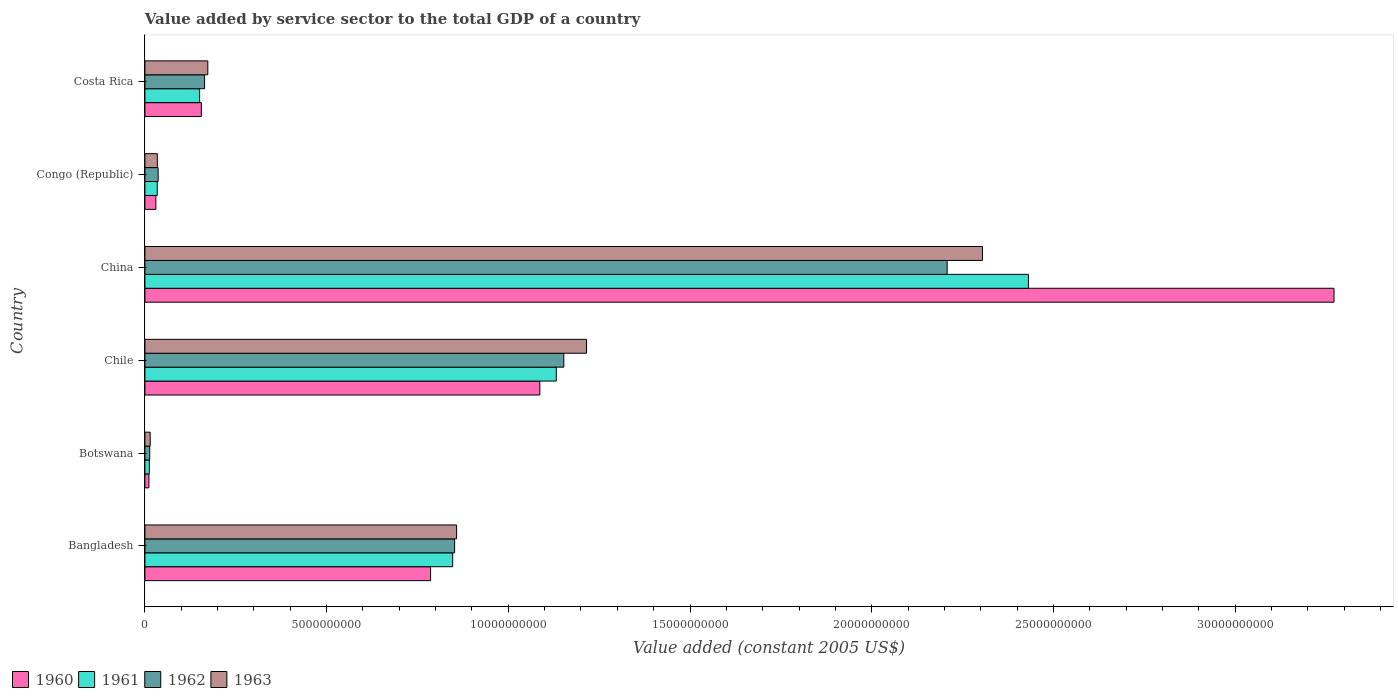How many different coloured bars are there?
Keep it short and to the point. 4. Are the number of bars per tick equal to the number of legend labels?
Give a very brief answer. Yes. How many bars are there on the 4th tick from the top?
Provide a succinct answer. 4. How many bars are there on the 3rd tick from the bottom?
Your answer should be very brief. 4. In how many cases, is the number of bars for a given country not equal to the number of legend labels?
Your response must be concise. 0. What is the value added by service sector in 1961 in Costa Rica?
Offer a very short reply. 1.51e+09. Across all countries, what is the maximum value added by service sector in 1963?
Make the answer very short. 2.30e+1. Across all countries, what is the minimum value added by service sector in 1961?
Provide a succinct answer. 1.22e+08. In which country was the value added by service sector in 1960 maximum?
Provide a short and direct response. China. In which country was the value added by service sector in 1960 minimum?
Offer a terse response. Botswana. What is the total value added by service sector in 1962 in the graph?
Keep it short and to the point. 4.43e+1. What is the difference between the value added by service sector in 1963 in Bangladesh and that in China?
Provide a succinct answer. -1.45e+1. What is the difference between the value added by service sector in 1963 in Botswana and the value added by service sector in 1961 in Costa Rica?
Your answer should be very brief. -1.36e+09. What is the average value added by service sector in 1960 per country?
Provide a short and direct response. 8.90e+09. What is the difference between the value added by service sector in 1960 and value added by service sector in 1962 in China?
Provide a short and direct response. 1.06e+1. What is the ratio of the value added by service sector in 1963 in Botswana to that in China?
Your answer should be compact. 0.01. Is the value added by service sector in 1963 in Botswana less than that in Congo (Republic)?
Offer a very short reply. Yes. Is the difference between the value added by service sector in 1960 in Congo (Republic) and Costa Rica greater than the difference between the value added by service sector in 1962 in Congo (Republic) and Costa Rica?
Offer a terse response. Yes. What is the difference between the highest and the second highest value added by service sector in 1963?
Provide a succinct answer. 1.09e+1. What is the difference between the highest and the lowest value added by service sector in 1963?
Give a very brief answer. 2.29e+1. What does the 3rd bar from the top in Costa Rica represents?
Your answer should be very brief. 1961. Is it the case that in every country, the sum of the value added by service sector in 1963 and value added by service sector in 1961 is greater than the value added by service sector in 1960?
Make the answer very short. Yes. How many bars are there?
Your answer should be very brief. 24. What is the difference between two consecutive major ticks on the X-axis?
Your response must be concise. 5.00e+09. Does the graph contain any zero values?
Your answer should be compact. No. Does the graph contain grids?
Ensure brevity in your answer.  No. How many legend labels are there?
Your answer should be compact. 4. How are the legend labels stacked?
Your answer should be very brief. Horizontal. What is the title of the graph?
Provide a succinct answer. Value added by service sector to the total GDP of a country. Does "1995" appear as one of the legend labels in the graph?
Give a very brief answer. No. What is the label or title of the X-axis?
Your answer should be very brief. Value added (constant 2005 US$). What is the label or title of the Y-axis?
Offer a very short reply. Country. What is the Value added (constant 2005 US$) in 1960 in Bangladesh?
Your answer should be very brief. 7.86e+09. What is the Value added (constant 2005 US$) of 1961 in Bangladesh?
Provide a succinct answer. 8.47e+09. What is the Value added (constant 2005 US$) of 1962 in Bangladesh?
Ensure brevity in your answer.  8.52e+09. What is the Value added (constant 2005 US$) of 1963 in Bangladesh?
Keep it short and to the point. 8.58e+09. What is the Value added (constant 2005 US$) of 1960 in Botswana?
Your answer should be compact. 1.11e+08. What is the Value added (constant 2005 US$) in 1961 in Botswana?
Your response must be concise. 1.22e+08. What is the Value added (constant 2005 US$) in 1962 in Botswana?
Provide a succinct answer. 1.32e+08. What is the Value added (constant 2005 US$) of 1963 in Botswana?
Provide a succinct answer. 1.45e+08. What is the Value added (constant 2005 US$) of 1960 in Chile?
Your answer should be compact. 1.09e+1. What is the Value added (constant 2005 US$) in 1961 in Chile?
Give a very brief answer. 1.13e+1. What is the Value added (constant 2005 US$) of 1962 in Chile?
Your response must be concise. 1.15e+1. What is the Value added (constant 2005 US$) in 1963 in Chile?
Ensure brevity in your answer.  1.22e+1. What is the Value added (constant 2005 US$) of 1960 in China?
Ensure brevity in your answer.  3.27e+1. What is the Value added (constant 2005 US$) in 1961 in China?
Ensure brevity in your answer.  2.43e+1. What is the Value added (constant 2005 US$) in 1962 in China?
Give a very brief answer. 2.21e+1. What is the Value added (constant 2005 US$) of 1963 in China?
Ensure brevity in your answer.  2.30e+1. What is the Value added (constant 2005 US$) in 1960 in Congo (Republic)?
Keep it short and to the point. 3.02e+08. What is the Value added (constant 2005 US$) in 1961 in Congo (Republic)?
Provide a succinct answer. 3.39e+08. What is the Value added (constant 2005 US$) of 1962 in Congo (Republic)?
Provide a succinct answer. 3.64e+08. What is the Value added (constant 2005 US$) in 1963 in Congo (Republic)?
Offer a very short reply. 3.42e+08. What is the Value added (constant 2005 US$) in 1960 in Costa Rica?
Your answer should be very brief. 1.55e+09. What is the Value added (constant 2005 US$) of 1961 in Costa Rica?
Give a very brief answer. 1.51e+09. What is the Value added (constant 2005 US$) of 1962 in Costa Rica?
Your response must be concise. 1.64e+09. What is the Value added (constant 2005 US$) of 1963 in Costa Rica?
Give a very brief answer. 1.73e+09. Across all countries, what is the maximum Value added (constant 2005 US$) in 1960?
Your answer should be very brief. 3.27e+1. Across all countries, what is the maximum Value added (constant 2005 US$) in 1961?
Offer a terse response. 2.43e+1. Across all countries, what is the maximum Value added (constant 2005 US$) of 1962?
Your answer should be very brief. 2.21e+1. Across all countries, what is the maximum Value added (constant 2005 US$) in 1963?
Keep it short and to the point. 2.30e+1. Across all countries, what is the minimum Value added (constant 2005 US$) of 1960?
Provide a short and direct response. 1.11e+08. Across all countries, what is the minimum Value added (constant 2005 US$) in 1961?
Offer a very short reply. 1.22e+08. Across all countries, what is the minimum Value added (constant 2005 US$) of 1962?
Your response must be concise. 1.32e+08. Across all countries, what is the minimum Value added (constant 2005 US$) of 1963?
Your answer should be very brief. 1.45e+08. What is the total Value added (constant 2005 US$) in 1960 in the graph?
Provide a short and direct response. 5.34e+1. What is the total Value added (constant 2005 US$) in 1961 in the graph?
Offer a very short reply. 4.61e+1. What is the total Value added (constant 2005 US$) of 1962 in the graph?
Your answer should be compact. 4.43e+1. What is the total Value added (constant 2005 US$) of 1963 in the graph?
Keep it short and to the point. 4.60e+1. What is the difference between the Value added (constant 2005 US$) of 1960 in Bangladesh and that in Botswana?
Offer a terse response. 7.75e+09. What is the difference between the Value added (constant 2005 US$) in 1961 in Bangladesh and that in Botswana?
Offer a terse response. 8.35e+09. What is the difference between the Value added (constant 2005 US$) of 1962 in Bangladesh and that in Botswana?
Offer a very short reply. 8.39e+09. What is the difference between the Value added (constant 2005 US$) of 1963 in Bangladesh and that in Botswana?
Offer a terse response. 8.43e+09. What is the difference between the Value added (constant 2005 US$) in 1960 in Bangladesh and that in Chile?
Make the answer very short. -3.01e+09. What is the difference between the Value added (constant 2005 US$) in 1961 in Bangladesh and that in Chile?
Provide a succinct answer. -2.85e+09. What is the difference between the Value added (constant 2005 US$) of 1962 in Bangladesh and that in Chile?
Keep it short and to the point. -3.00e+09. What is the difference between the Value added (constant 2005 US$) of 1963 in Bangladesh and that in Chile?
Your answer should be very brief. -3.58e+09. What is the difference between the Value added (constant 2005 US$) of 1960 in Bangladesh and that in China?
Ensure brevity in your answer.  -2.49e+1. What is the difference between the Value added (constant 2005 US$) of 1961 in Bangladesh and that in China?
Offer a terse response. -1.58e+1. What is the difference between the Value added (constant 2005 US$) in 1962 in Bangladesh and that in China?
Make the answer very short. -1.36e+1. What is the difference between the Value added (constant 2005 US$) in 1963 in Bangladesh and that in China?
Keep it short and to the point. -1.45e+1. What is the difference between the Value added (constant 2005 US$) in 1960 in Bangladesh and that in Congo (Republic)?
Your answer should be very brief. 7.56e+09. What is the difference between the Value added (constant 2005 US$) of 1961 in Bangladesh and that in Congo (Republic)?
Make the answer very short. 8.13e+09. What is the difference between the Value added (constant 2005 US$) in 1962 in Bangladesh and that in Congo (Republic)?
Your response must be concise. 8.16e+09. What is the difference between the Value added (constant 2005 US$) in 1963 in Bangladesh and that in Congo (Republic)?
Provide a short and direct response. 8.24e+09. What is the difference between the Value added (constant 2005 US$) in 1960 in Bangladesh and that in Costa Rica?
Give a very brief answer. 6.31e+09. What is the difference between the Value added (constant 2005 US$) of 1961 in Bangladesh and that in Costa Rica?
Your answer should be compact. 6.96e+09. What is the difference between the Value added (constant 2005 US$) of 1962 in Bangladesh and that in Costa Rica?
Keep it short and to the point. 6.88e+09. What is the difference between the Value added (constant 2005 US$) of 1963 in Bangladesh and that in Costa Rica?
Provide a succinct answer. 6.85e+09. What is the difference between the Value added (constant 2005 US$) of 1960 in Botswana and that in Chile?
Your answer should be very brief. -1.08e+1. What is the difference between the Value added (constant 2005 US$) in 1961 in Botswana and that in Chile?
Your response must be concise. -1.12e+1. What is the difference between the Value added (constant 2005 US$) in 1962 in Botswana and that in Chile?
Your response must be concise. -1.14e+1. What is the difference between the Value added (constant 2005 US$) of 1963 in Botswana and that in Chile?
Provide a short and direct response. -1.20e+1. What is the difference between the Value added (constant 2005 US$) in 1960 in Botswana and that in China?
Keep it short and to the point. -3.26e+1. What is the difference between the Value added (constant 2005 US$) of 1961 in Botswana and that in China?
Give a very brief answer. -2.42e+1. What is the difference between the Value added (constant 2005 US$) of 1962 in Botswana and that in China?
Your answer should be very brief. -2.19e+1. What is the difference between the Value added (constant 2005 US$) in 1963 in Botswana and that in China?
Your answer should be very brief. -2.29e+1. What is the difference between the Value added (constant 2005 US$) of 1960 in Botswana and that in Congo (Republic)?
Your response must be concise. -1.91e+08. What is the difference between the Value added (constant 2005 US$) of 1961 in Botswana and that in Congo (Republic)?
Make the answer very short. -2.17e+08. What is the difference between the Value added (constant 2005 US$) of 1962 in Botswana and that in Congo (Republic)?
Make the answer very short. -2.32e+08. What is the difference between the Value added (constant 2005 US$) of 1963 in Botswana and that in Congo (Republic)?
Make the answer very short. -1.97e+08. What is the difference between the Value added (constant 2005 US$) of 1960 in Botswana and that in Costa Rica?
Your response must be concise. -1.44e+09. What is the difference between the Value added (constant 2005 US$) of 1961 in Botswana and that in Costa Rica?
Provide a succinct answer. -1.38e+09. What is the difference between the Value added (constant 2005 US$) of 1962 in Botswana and that in Costa Rica?
Your answer should be very brief. -1.51e+09. What is the difference between the Value added (constant 2005 US$) of 1963 in Botswana and that in Costa Rica?
Provide a succinct answer. -1.59e+09. What is the difference between the Value added (constant 2005 US$) of 1960 in Chile and that in China?
Make the answer very short. -2.19e+1. What is the difference between the Value added (constant 2005 US$) of 1961 in Chile and that in China?
Your answer should be very brief. -1.30e+1. What is the difference between the Value added (constant 2005 US$) in 1962 in Chile and that in China?
Ensure brevity in your answer.  -1.05e+1. What is the difference between the Value added (constant 2005 US$) of 1963 in Chile and that in China?
Provide a succinct answer. -1.09e+1. What is the difference between the Value added (constant 2005 US$) of 1960 in Chile and that in Congo (Republic)?
Offer a terse response. 1.06e+1. What is the difference between the Value added (constant 2005 US$) in 1961 in Chile and that in Congo (Republic)?
Provide a succinct answer. 1.10e+1. What is the difference between the Value added (constant 2005 US$) of 1962 in Chile and that in Congo (Republic)?
Your response must be concise. 1.12e+1. What is the difference between the Value added (constant 2005 US$) of 1963 in Chile and that in Congo (Republic)?
Provide a succinct answer. 1.18e+1. What is the difference between the Value added (constant 2005 US$) in 1960 in Chile and that in Costa Rica?
Keep it short and to the point. 9.31e+09. What is the difference between the Value added (constant 2005 US$) of 1961 in Chile and that in Costa Rica?
Provide a short and direct response. 9.81e+09. What is the difference between the Value added (constant 2005 US$) in 1962 in Chile and that in Costa Rica?
Your response must be concise. 9.89e+09. What is the difference between the Value added (constant 2005 US$) of 1963 in Chile and that in Costa Rica?
Your answer should be very brief. 1.04e+1. What is the difference between the Value added (constant 2005 US$) in 1960 in China and that in Congo (Republic)?
Keep it short and to the point. 3.24e+1. What is the difference between the Value added (constant 2005 US$) of 1961 in China and that in Congo (Republic)?
Offer a terse response. 2.40e+1. What is the difference between the Value added (constant 2005 US$) in 1962 in China and that in Congo (Republic)?
Offer a very short reply. 2.17e+1. What is the difference between the Value added (constant 2005 US$) of 1963 in China and that in Congo (Republic)?
Your answer should be compact. 2.27e+1. What is the difference between the Value added (constant 2005 US$) of 1960 in China and that in Costa Rica?
Give a very brief answer. 3.12e+1. What is the difference between the Value added (constant 2005 US$) in 1961 in China and that in Costa Rica?
Provide a short and direct response. 2.28e+1. What is the difference between the Value added (constant 2005 US$) of 1962 in China and that in Costa Rica?
Your answer should be very brief. 2.04e+1. What is the difference between the Value added (constant 2005 US$) in 1963 in China and that in Costa Rica?
Offer a terse response. 2.13e+1. What is the difference between the Value added (constant 2005 US$) in 1960 in Congo (Republic) and that in Costa Rica?
Offer a terse response. -1.25e+09. What is the difference between the Value added (constant 2005 US$) of 1961 in Congo (Republic) and that in Costa Rica?
Make the answer very short. -1.17e+09. What is the difference between the Value added (constant 2005 US$) in 1962 in Congo (Republic) and that in Costa Rica?
Your answer should be compact. -1.28e+09. What is the difference between the Value added (constant 2005 US$) in 1963 in Congo (Republic) and that in Costa Rica?
Offer a very short reply. -1.39e+09. What is the difference between the Value added (constant 2005 US$) in 1960 in Bangladesh and the Value added (constant 2005 US$) in 1961 in Botswana?
Your response must be concise. 7.74e+09. What is the difference between the Value added (constant 2005 US$) in 1960 in Bangladesh and the Value added (constant 2005 US$) in 1962 in Botswana?
Ensure brevity in your answer.  7.73e+09. What is the difference between the Value added (constant 2005 US$) in 1960 in Bangladesh and the Value added (constant 2005 US$) in 1963 in Botswana?
Offer a terse response. 7.72e+09. What is the difference between the Value added (constant 2005 US$) in 1961 in Bangladesh and the Value added (constant 2005 US$) in 1962 in Botswana?
Your answer should be very brief. 8.34e+09. What is the difference between the Value added (constant 2005 US$) of 1961 in Bangladesh and the Value added (constant 2005 US$) of 1963 in Botswana?
Your answer should be very brief. 8.32e+09. What is the difference between the Value added (constant 2005 US$) in 1962 in Bangladesh and the Value added (constant 2005 US$) in 1963 in Botswana?
Your answer should be compact. 8.38e+09. What is the difference between the Value added (constant 2005 US$) of 1960 in Bangladesh and the Value added (constant 2005 US$) of 1961 in Chile?
Ensure brevity in your answer.  -3.46e+09. What is the difference between the Value added (constant 2005 US$) in 1960 in Bangladesh and the Value added (constant 2005 US$) in 1962 in Chile?
Your answer should be very brief. -3.67e+09. What is the difference between the Value added (constant 2005 US$) of 1960 in Bangladesh and the Value added (constant 2005 US$) of 1963 in Chile?
Your response must be concise. -4.29e+09. What is the difference between the Value added (constant 2005 US$) of 1961 in Bangladesh and the Value added (constant 2005 US$) of 1962 in Chile?
Offer a very short reply. -3.06e+09. What is the difference between the Value added (constant 2005 US$) in 1961 in Bangladesh and the Value added (constant 2005 US$) in 1963 in Chile?
Your answer should be compact. -3.68e+09. What is the difference between the Value added (constant 2005 US$) in 1962 in Bangladesh and the Value added (constant 2005 US$) in 1963 in Chile?
Provide a succinct answer. -3.63e+09. What is the difference between the Value added (constant 2005 US$) in 1960 in Bangladesh and the Value added (constant 2005 US$) in 1961 in China?
Give a very brief answer. -1.65e+1. What is the difference between the Value added (constant 2005 US$) of 1960 in Bangladesh and the Value added (constant 2005 US$) of 1962 in China?
Offer a terse response. -1.42e+1. What is the difference between the Value added (constant 2005 US$) in 1960 in Bangladesh and the Value added (constant 2005 US$) in 1963 in China?
Your answer should be compact. -1.52e+1. What is the difference between the Value added (constant 2005 US$) in 1961 in Bangladesh and the Value added (constant 2005 US$) in 1962 in China?
Provide a short and direct response. -1.36e+1. What is the difference between the Value added (constant 2005 US$) of 1961 in Bangladesh and the Value added (constant 2005 US$) of 1963 in China?
Give a very brief answer. -1.46e+1. What is the difference between the Value added (constant 2005 US$) in 1962 in Bangladesh and the Value added (constant 2005 US$) in 1963 in China?
Keep it short and to the point. -1.45e+1. What is the difference between the Value added (constant 2005 US$) in 1960 in Bangladesh and the Value added (constant 2005 US$) in 1961 in Congo (Republic)?
Your answer should be very brief. 7.52e+09. What is the difference between the Value added (constant 2005 US$) in 1960 in Bangladesh and the Value added (constant 2005 US$) in 1962 in Congo (Republic)?
Your response must be concise. 7.50e+09. What is the difference between the Value added (constant 2005 US$) of 1960 in Bangladesh and the Value added (constant 2005 US$) of 1963 in Congo (Republic)?
Offer a terse response. 7.52e+09. What is the difference between the Value added (constant 2005 US$) in 1961 in Bangladesh and the Value added (constant 2005 US$) in 1962 in Congo (Republic)?
Your response must be concise. 8.11e+09. What is the difference between the Value added (constant 2005 US$) of 1961 in Bangladesh and the Value added (constant 2005 US$) of 1963 in Congo (Republic)?
Provide a succinct answer. 8.13e+09. What is the difference between the Value added (constant 2005 US$) of 1962 in Bangladesh and the Value added (constant 2005 US$) of 1963 in Congo (Republic)?
Your answer should be compact. 8.18e+09. What is the difference between the Value added (constant 2005 US$) of 1960 in Bangladesh and the Value added (constant 2005 US$) of 1961 in Costa Rica?
Provide a succinct answer. 6.36e+09. What is the difference between the Value added (constant 2005 US$) in 1960 in Bangladesh and the Value added (constant 2005 US$) in 1962 in Costa Rica?
Your response must be concise. 6.22e+09. What is the difference between the Value added (constant 2005 US$) of 1960 in Bangladesh and the Value added (constant 2005 US$) of 1963 in Costa Rica?
Make the answer very short. 6.13e+09. What is the difference between the Value added (constant 2005 US$) of 1961 in Bangladesh and the Value added (constant 2005 US$) of 1962 in Costa Rica?
Your answer should be compact. 6.83e+09. What is the difference between the Value added (constant 2005 US$) of 1961 in Bangladesh and the Value added (constant 2005 US$) of 1963 in Costa Rica?
Offer a very short reply. 6.74e+09. What is the difference between the Value added (constant 2005 US$) in 1962 in Bangladesh and the Value added (constant 2005 US$) in 1963 in Costa Rica?
Give a very brief answer. 6.79e+09. What is the difference between the Value added (constant 2005 US$) of 1960 in Botswana and the Value added (constant 2005 US$) of 1961 in Chile?
Ensure brevity in your answer.  -1.12e+1. What is the difference between the Value added (constant 2005 US$) in 1960 in Botswana and the Value added (constant 2005 US$) in 1962 in Chile?
Provide a short and direct response. -1.14e+1. What is the difference between the Value added (constant 2005 US$) of 1960 in Botswana and the Value added (constant 2005 US$) of 1963 in Chile?
Offer a terse response. -1.20e+1. What is the difference between the Value added (constant 2005 US$) in 1961 in Botswana and the Value added (constant 2005 US$) in 1962 in Chile?
Offer a very short reply. -1.14e+1. What is the difference between the Value added (constant 2005 US$) of 1961 in Botswana and the Value added (constant 2005 US$) of 1963 in Chile?
Your answer should be compact. -1.20e+1. What is the difference between the Value added (constant 2005 US$) of 1962 in Botswana and the Value added (constant 2005 US$) of 1963 in Chile?
Keep it short and to the point. -1.20e+1. What is the difference between the Value added (constant 2005 US$) in 1960 in Botswana and the Value added (constant 2005 US$) in 1961 in China?
Offer a terse response. -2.42e+1. What is the difference between the Value added (constant 2005 US$) in 1960 in Botswana and the Value added (constant 2005 US$) in 1962 in China?
Offer a terse response. -2.20e+1. What is the difference between the Value added (constant 2005 US$) of 1960 in Botswana and the Value added (constant 2005 US$) of 1963 in China?
Provide a succinct answer. -2.29e+1. What is the difference between the Value added (constant 2005 US$) of 1961 in Botswana and the Value added (constant 2005 US$) of 1962 in China?
Ensure brevity in your answer.  -2.20e+1. What is the difference between the Value added (constant 2005 US$) in 1961 in Botswana and the Value added (constant 2005 US$) in 1963 in China?
Offer a very short reply. -2.29e+1. What is the difference between the Value added (constant 2005 US$) of 1962 in Botswana and the Value added (constant 2005 US$) of 1963 in China?
Offer a terse response. -2.29e+1. What is the difference between the Value added (constant 2005 US$) of 1960 in Botswana and the Value added (constant 2005 US$) of 1961 in Congo (Republic)?
Your answer should be compact. -2.28e+08. What is the difference between the Value added (constant 2005 US$) in 1960 in Botswana and the Value added (constant 2005 US$) in 1962 in Congo (Republic)?
Give a very brief answer. -2.53e+08. What is the difference between the Value added (constant 2005 US$) of 1960 in Botswana and the Value added (constant 2005 US$) of 1963 in Congo (Republic)?
Provide a succinct answer. -2.31e+08. What is the difference between the Value added (constant 2005 US$) of 1961 in Botswana and the Value added (constant 2005 US$) of 1962 in Congo (Republic)?
Your response must be concise. -2.42e+08. What is the difference between the Value added (constant 2005 US$) in 1961 in Botswana and the Value added (constant 2005 US$) in 1963 in Congo (Republic)?
Provide a short and direct response. -2.20e+08. What is the difference between the Value added (constant 2005 US$) of 1962 in Botswana and the Value added (constant 2005 US$) of 1963 in Congo (Republic)?
Keep it short and to the point. -2.10e+08. What is the difference between the Value added (constant 2005 US$) of 1960 in Botswana and the Value added (constant 2005 US$) of 1961 in Costa Rica?
Your answer should be very brief. -1.39e+09. What is the difference between the Value added (constant 2005 US$) of 1960 in Botswana and the Value added (constant 2005 US$) of 1962 in Costa Rica?
Make the answer very short. -1.53e+09. What is the difference between the Value added (constant 2005 US$) of 1960 in Botswana and the Value added (constant 2005 US$) of 1963 in Costa Rica?
Ensure brevity in your answer.  -1.62e+09. What is the difference between the Value added (constant 2005 US$) of 1961 in Botswana and the Value added (constant 2005 US$) of 1962 in Costa Rica?
Provide a succinct answer. -1.52e+09. What is the difference between the Value added (constant 2005 US$) in 1961 in Botswana and the Value added (constant 2005 US$) in 1963 in Costa Rica?
Keep it short and to the point. -1.61e+09. What is the difference between the Value added (constant 2005 US$) in 1962 in Botswana and the Value added (constant 2005 US$) in 1963 in Costa Rica?
Make the answer very short. -1.60e+09. What is the difference between the Value added (constant 2005 US$) of 1960 in Chile and the Value added (constant 2005 US$) of 1961 in China?
Your answer should be compact. -1.34e+1. What is the difference between the Value added (constant 2005 US$) of 1960 in Chile and the Value added (constant 2005 US$) of 1962 in China?
Provide a succinct answer. -1.12e+1. What is the difference between the Value added (constant 2005 US$) in 1960 in Chile and the Value added (constant 2005 US$) in 1963 in China?
Your answer should be very brief. -1.22e+1. What is the difference between the Value added (constant 2005 US$) in 1961 in Chile and the Value added (constant 2005 US$) in 1962 in China?
Offer a very short reply. -1.08e+1. What is the difference between the Value added (constant 2005 US$) in 1961 in Chile and the Value added (constant 2005 US$) in 1963 in China?
Provide a short and direct response. -1.17e+1. What is the difference between the Value added (constant 2005 US$) in 1962 in Chile and the Value added (constant 2005 US$) in 1963 in China?
Make the answer very short. -1.15e+1. What is the difference between the Value added (constant 2005 US$) of 1960 in Chile and the Value added (constant 2005 US$) of 1961 in Congo (Republic)?
Keep it short and to the point. 1.05e+1. What is the difference between the Value added (constant 2005 US$) in 1960 in Chile and the Value added (constant 2005 US$) in 1962 in Congo (Republic)?
Your answer should be very brief. 1.05e+1. What is the difference between the Value added (constant 2005 US$) of 1960 in Chile and the Value added (constant 2005 US$) of 1963 in Congo (Republic)?
Your answer should be compact. 1.05e+1. What is the difference between the Value added (constant 2005 US$) in 1961 in Chile and the Value added (constant 2005 US$) in 1962 in Congo (Republic)?
Your answer should be compact. 1.10e+1. What is the difference between the Value added (constant 2005 US$) in 1961 in Chile and the Value added (constant 2005 US$) in 1963 in Congo (Republic)?
Your answer should be compact. 1.10e+1. What is the difference between the Value added (constant 2005 US$) in 1962 in Chile and the Value added (constant 2005 US$) in 1963 in Congo (Republic)?
Your answer should be very brief. 1.12e+1. What is the difference between the Value added (constant 2005 US$) of 1960 in Chile and the Value added (constant 2005 US$) of 1961 in Costa Rica?
Offer a terse response. 9.36e+09. What is the difference between the Value added (constant 2005 US$) of 1960 in Chile and the Value added (constant 2005 US$) of 1962 in Costa Rica?
Ensure brevity in your answer.  9.23e+09. What is the difference between the Value added (constant 2005 US$) of 1960 in Chile and the Value added (constant 2005 US$) of 1963 in Costa Rica?
Your response must be concise. 9.14e+09. What is the difference between the Value added (constant 2005 US$) in 1961 in Chile and the Value added (constant 2005 US$) in 1962 in Costa Rica?
Your answer should be compact. 9.68e+09. What is the difference between the Value added (constant 2005 US$) of 1961 in Chile and the Value added (constant 2005 US$) of 1963 in Costa Rica?
Offer a terse response. 9.59e+09. What is the difference between the Value added (constant 2005 US$) of 1962 in Chile and the Value added (constant 2005 US$) of 1963 in Costa Rica?
Keep it short and to the point. 9.80e+09. What is the difference between the Value added (constant 2005 US$) of 1960 in China and the Value added (constant 2005 US$) of 1961 in Congo (Republic)?
Provide a succinct answer. 3.24e+1. What is the difference between the Value added (constant 2005 US$) of 1960 in China and the Value added (constant 2005 US$) of 1962 in Congo (Republic)?
Provide a succinct answer. 3.24e+1. What is the difference between the Value added (constant 2005 US$) of 1960 in China and the Value added (constant 2005 US$) of 1963 in Congo (Republic)?
Offer a very short reply. 3.24e+1. What is the difference between the Value added (constant 2005 US$) of 1961 in China and the Value added (constant 2005 US$) of 1962 in Congo (Republic)?
Provide a succinct answer. 2.39e+1. What is the difference between the Value added (constant 2005 US$) of 1961 in China and the Value added (constant 2005 US$) of 1963 in Congo (Republic)?
Provide a short and direct response. 2.40e+1. What is the difference between the Value added (constant 2005 US$) of 1962 in China and the Value added (constant 2005 US$) of 1963 in Congo (Republic)?
Your answer should be compact. 2.17e+1. What is the difference between the Value added (constant 2005 US$) in 1960 in China and the Value added (constant 2005 US$) in 1961 in Costa Rica?
Your response must be concise. 3.12e+1. What is the difference between the Value added (constant 2005 US$) in 1960 in China and the Value added (constant 2005 US$) in 1962 in Costa Rica?
Provide a short and direct response. 3.11e+1. What is the difference between the Value added (constant 2005 US$) of 1960 in China and the Value added (constant 2005 US$) of 1963 in Costa Rica?
Make the answer very short. 3.10e+1. What is the difference between the Value added (constant 2005 US$) in 1961 in China and the Value added (constant 2005 US$) in 1962 in Costa Rica?
Offer a very short reply. 2.27e+1. What is the difference between the Value added (constant 2005 US$) in 1961 in China and the Value added (constant 2005 US$) in 1963 in Costa Rica?
Your response must be concise. 2.26e+1. What is the difference between the Value added (constant 2005 US$) of 1962 in China and the Value added (constant 2005 US$) of 1963 in Costa Rica?
Your answer should be very brief. 2.03e+1. What is the difference between the Value added (constant 2005 US$) of 1960 in Congo (Republic) and the Value added (constant 2005 US$) of 1961 in Costa Rica?
Offer a very short reply. -1.20e+09. What is the difference between the Value added (constant 2005 US$) of 1960 in Congo (Republic) and the Value added (constant 2005 US$) of 1962 in Costa Rica?
Ensure brevity in your answer.  -1.34e+09. What is the difference between the Value added (constant 2005 US$) of 1960 in Congo (Republic) and the Value added (constant 2005 US$) of 1963 in Costa Rica?
Your response must be concise. -1.43e+09. What is the difference between the Value added (constant 2005 US$) in 1961 in Congo (Republic) and the Value added (constant 2005 US$) in 1962 in Costa Rica?
Keep it short and to the point. -1.30e+09. What is the difference between the Value added (constant 2005 US$) in 1961 in Congo (Republic) and the Value added (constant 2005 US$) in 1963 in Costa Rica?
Make the answer very short. -1.39e+09. What is the difference between the Value added (constant 2005 US$) in 1962 in Congo (Republic) and the Value added (constant 2005 US$) in 1963 in Costa Rica?
Your answer should be compact. -1.37e+09. What is the average Value added (constant 2005 US$) in 1960 per country?
Offer a terse response. 8.90e+09. What is the average Value added (constant 2005 US$) in 1961 per country?
Offer a terse response. 7.68e+09. What is the average Value added (constant 2005 US$) of 1962 per country?
Offer a terse response. 7.38e+09. What is the average Value added (constant 2005 US$) of 1963 per country?
Your response must be concise. 7.67e+09. What is the difference between the Value added (constant 2005 US$) in 1960 and Value added (constant 2005 US$) in 1961 in Bangladesh?
Ensure brevity in your answer.  -6.09e+08. What is the difference between the Value added (constant 2005 US$) of 1960 and Value added (constant 2005 US$) of 1962 in Bangladesh?
Offer a very short reply. -6.62e+08. What is the difference between the Value added (constant 2005 US$) of 1960 and Value added (constant 2005 US$) of 1963 in Bangladesh?
Provide a succinct answer. -7.16e+08. What is the difference between the Value added (constant 2005 US$) in 1961 and Value added (constant 2005 US$) in 1962 in Bangladesh?
Keep it short and to the point. -5.33e+07. What is the difference between the Value added (constant 2005 US$) of 1961 and Value added (constant 2005 US$) of 1963 in Bangladesh?
Your response must be concise. -1.08e+08. What is the difference between the Value added (constant 2005 US$) of 1962 and Value added (constant 2005 US$) of 1963 in Bangladesh?
Give a very brief answer. -5.45e+07. What is the difference between the Value added (constant 2005 US$) of 1960 and Value added (constant 2005 US$) of 1961 in Botswana?
Your answer should be very brief. -1.12e+07. What is the difference between the Value added (constant 2005 US$) in 1960 and Value added (constant 2005 US$) in 1962 in Botswana?
Keep it short and to the point. -2.17e+07. What is the difference between the Value added (constant 2005 US$) of 1960 and Value added (constant 2005 US$) of 1963 in Botswana?
Make the answer very short. -3.45e+07. What is the difference between the Value added (constant 2005 US$) of 1961 and Value added (constant 2005 US$) of 1962 in Botswana?
Offer a very short reply. -1.05e+07. What is the difference between the Value added (constant 2005 US$) in 1961 and Value added (constant 2005 US$) in 1963 in Botswana?
Keep it short and to the point. -2.33e+07. What is the difference between the Value added (constant 2005 US$) in 1962 and Value added (constant 2005 US$) in 1963 in Botswana?
Give a very brief answer. -1.28e+07. What is the difference between the Value added (constant 2005 US$) in 1960 and Value added (constant 2005 US$) in 1961 in Chile?
Ensure brevity in your answer.  -4.53e+08. What is the difference between the Value added (constant 2005 US$) of 1960 and Value added (constant 2005 US$) of 1962 in Chile?
Provide a succinct answer. -6.60e+08. What is the difference between the Value added (constant 2005 US$) of 1960 and Value added (constant 2005 US$) of 1963 in Chile?
Your response must be concise. -1.29e+09. What is the difference between the Value added (constant 2005 US$) of 1961 and Value added (constant 2005 US$) of 1962 in Chile?
Make the answer very short. -2.07e+08. What is the difference between the Value added (constant 2005 US$) in 1961 and Value added (constant 2005 US$) in 1963 in Chile?
Your answer should be very brief. -8.32e+08. What is the difference between the Value added (constant 2005 US$) in 1962 and Value added (constant 2005 US$) in 1963 in Chile?
Keep it short and to the point. -6.25e+08. What is the difference between the Value added (constant 2005 US$) of 1960 and Value added (constant 2005 US$) of 1961 in China?
Offer a terse response. 8.41e+09. What is the difference between the Value added (constant 2005 US$) in 1960 and Value added (constant 2005 US$) in 1962 in China?
Ensure brevity in your answer.  1.06e+1. What is the difference between the Value added (constant 2005 US$) in 1960 and Value added (constant 2005 US$) in 1963 in China?
Offer a terse response. 9.68e+09. What is the difference between the Value added (constant 2005 US$) in 1961 and Value added (constant 2005 US$) in 1962 in China?
Provide a succinct answer. 2.24e+09. What is the difference between the Value added (constant 2005 US$) in 1961 and Value added (constant 2005 US$) in 1963 in China?
Ensure brevity in your answer.  1.27e+09. What is the difference between the Value added (constant 2005 US$) in 1962 and Value added (constant 2005 US$) in 1963 in China?
Your answer should be very brief. -9.71e+08. What is the difference between the Value added (constant 2005 US$) in 1960 and Value added (constant 2005 US$) in 1961 in Congo (Republic)?
Ensure brevity in your answer.  -3.74e+07. What is the difference between the Value added (constant 2005 US$) in 1960 and Value added (constant 2005 US$) in 1962 in Congo (Republic)?
Give a very brief answer. -6.23e+07. What is the difference between the Value added (constant 2005 US$) in 1960 and Value added (constant 2005 US$) in 1963 in Congo (Republic)?
Ensure brevity in your answer.  -4.05e+07. What is the difference between the Value added (constant 2005 US$) of 1961 and Value added (constant 2005 US$) of 1962 in Congo (Republic)?
Give a very brief answer. -2.49e+07. What is the difference between the Value added (constant 2005 US$) in 1961 and Value added (constant 2005 US$) in 1963 in Congo (Republic)?
Offer a terse response. -3.09e+06. What is the difference between the Value added (constant 2005 US$) of 1962 and Value added (constant 2005 US$) of 1963 in Congo (Republic)?
Offer a terse response. 2.18e+07. What is the difference between the Value added (constant 2005 US$) of 1960 and Value added (constant 2005 US$) of 1961 in Costa Rica?
Make the answer very short. 4.72e+07. What is the difference between the Value added (constant 2005 US$) in 1960 and Value added (constant 2005 US$) in 1962 in Costa Rica?
Your answer should be very brief. -8.87e+07. What is the difference between the Value added (constant 2005 US$) of 1960 and Value added (constant 2005 US$) of 1963 in Costa Rica?
Your response must be concise. -1.78e+08. What is the difference between the Value added (constant 2005 US$) of 1961 and Value added (constant 2005 US$) of 1962 in Costa Rica?
Keep it short and to the point. -1.36e+08. What is the difference between the Value added (constant 2005 US$) of 1961 and Value added (constant 2005 US$) of 1963 in Costa Rica?
Offer a very short reply. -2.25e+08. What is the difference between the Value added (constant 2005 US$) of 1962 and Value added (constant 2005 US$) of 1963 in Costa Rica?
Your answer should be very brief. -8.94e+07. What is the ratio of the Value added (constant 2005 US$) in 1960 in Bangladesh to that in Botswana?
Provide a succinct answer. 71.09. What is the ratio of the Value added (constant 2005 US$) in 1961 in Bangladesh to that in Botswana?
Make the answer very short. 69.55. What is the ratio of the Value added (constant 2005 US$) of 1962 in Bangladesh to that in Botswana?
Provide a succinct answer. 64.43. What is the ratio of the Value added (constant 2005 US$) of 1963 in Bangladesh to that in Botswana?
Your answer should be compact. 59.12. What is the ratio of the Value added (constant 2005 US$) of 1960 in Bangladesh to that in Chile?
Provide a short and direct response. 0.72. What is the ratio of the Value added (constant 2005 US$) of 1961 in Bangladesh to that in Chile?
Your answer should be very brief. 0.75. What is the ratio of the Value added (constant 2005 US$) of 1962 in Bangladesh to that in Chile?
Provide a short and direct response. 0.74. What is the ratio of the Value added (constant 2005 US$) in 1963 in Bangladesh to that in Chile?
Provide a succinct answer. 0.71. What is the ratio of the Value added (constant 2005 US$) of 1960 in Bangladesh to that in China?
Ensure brevity in your answer.  0.24. What is the ratio of the Value added (constant 2005 US$) in 1961 in Bangladesh to that in China?
Ensure brevity in your answer.  0.35. What is the ratio of the Value added (constant 2005 US$) of 1962 in Bangladesh to that in China?
Give a very brief answer. 0.39. What is the ratio of the Value added (constant 2005 US$) of 1963 in Bangladesh to that in China?
Provide a succinct answer. 0.37. What is the ratio of the Value added (constant 2005 US$) of 1960 in Bangladesh to that in Congo (Republic)?
Offer a very short reply. 26.07. What is the ratio of the Value added (constant 2005 US$) in 1961 in Bangladesh to that in Congo (Republic)?
Give a very brief answer. 24.99. What is the ratio of the Value added (constant 2005 US$) in 1962 in Bangladesh to that in Congo (Republic)?
Ensure brevity in your answer.  23.42. What is the ratio of the Value added (constant 2005 US$) of 1963 in Bangladesh to that in Congo (Republic)?
Your answer should be very brief. 25.08. What is the ratio of the Value added (constant 2005 US$) of 1960 in Bangladesh to that in Costa Rica?
Give a very brief answer. 5.06. What is the ratio of the Value added (constant 2005 US$) of 1961 in Bangladesh to that in Costa Rica?
Offer a terse response. 5.63. What is the ratio of the Value added (constant 2005 US$) in 1962 in Bangladesh to that in Costa Rica?
Offer a very short reply. 5.19. What is the ratio of the Value added (constant 2005 US$) in 1963 in Bangladesh to that in Costa Rica?
Your answer should be compact. 4.96. What is the ratio of the Value added (constant 2005 US$) in 1960 in Botswana to that in Chile?
Keep it short and to the point. 0.01. What is the ratio of the Value added (constant 2005 US$) of 1961 in Botswana to that in Chile?
Your answer should be very brief. 0.01. What is the ratio of the Value added (constant 2005 US$) in 1962 in Botswana to that in Chile?
Offer a very short reply. 0.01. What is the ratio of the Value added (constant 2005 US$) in 1963 in Botswana to that in Chile?
Make the answer very short. 0.01. What is the ratio of the Value added (constant 2005 US$) of 1960 in Botswana to that in China?
Provide a short and direct response. 0. What is the ratio of the Value added (constant 2005 US$) of 1961 in Botswana to that in China?
Provide a succinct answer. 0.01. What is the ratio of the Value added (constant 2005 US$) of 1962 in Botswana to that in China?
Make the answer very short. 0.01. What is the ratio of the Value added (constant 2005 US$) of 1963 in Botswana to that in China?
Your answer should be very brief. 0.01. What is the ratio of the Value added (constant 2005 US$) of 1960 in Botswana to that in Congo (Republic)?
Give a very brief answer. 0.37. What is the ratio of the Value added (constant 2005 US$) of 1961 in Botswana to that in Congo (Republic)?
Your response must be concise. 0.36. What is the ratio of the Value added (constant 2005 US$) in 1962 in Botswana to that in Congo (Republic)?
Give a very brief answer. 0.36. What is the ratio of the Value added (constant 2005 US$) in 1963 in Botswana to that in Congo (Republic)?
Make the answer very short. 0.42. What is the ratio of the Value added (constant 2005 US$) of 1960 in Botswana to that in Costa Rica?
Ensure brevity in your answer.  0.07. What is the ratio of the Value added (constant 2005 US$) in 1961 in Botswana to that in Costa Rica?
Offer a very short reply. 0.08. What is the ratio of the Value added (constant 2005 US$) in 1962 in Botswana to that in Costa Rica?
Your answer should be compact. 0.08. What is the ratio of the Value added (constant 2005 US$) of 1963 in Botswana to that in Costa Rica?
Provide a short and direct response. 0.08. What is the ratio of the Value added (constant 2005 US$) of 1960 in Chile to that in China?
Your response must be concise. 0.33. What is the ratio of the Value added (constant 2005 US$) in 1961 in Chile to that in China?
Keep it short and to the point. 0.47. What is the ratio of the Value added (constant 2005 US$) of 1962 in Chile to that in China?
Provide a succinct answer. 0.52. What is the ratio of the Value added (constant 2005 US$) of 1963 in Chile to that in China?
Keep it short and to the point. 0.53. What is the ratio of the Value added (constant 2005 US$) of 1960 in Chile to that in Congo (Republic)?
Provide a succinct answer. 36.04. What is the ratio of the Value added (constant 2005 US$) of 1961 in Chile to that in Congo (Republic)?
Provide a short and direct response. 33.4. What is the ratio of the Value added (constant 2005 US$) in 1962 in Chile to that in Congo (Republic)?
Ensure brevity in your answer.  31.68. What is the ratio of the Value added (constant 2005 US$) of 1963 in Chile to that in Congo (Republic)?
Your answer should be compact. 35.53. What is the ratio of the Value added (constant 2005 US$) in 1960 in Chile to that in Costa Rica?
Your answer should be very brief. 7. What is the ratio of the Value added (constant 2005 US$) of 1961 in Chile to that in Costa Rica?
Provide a succinct answer. 7.52. What is the ratio of the Value added (constant 2005 US$) of 1962 in Chile to that in Costa Rica?
Make the answer very short. 7.02. What is the ratio of the Value added (constant 2005 US$) of 1963 in Chile to that in Costa Rica?
Provide a succinct answer. 7.02. What is the ratio of the Value added (constant 2005 US$) in 1960 in China to that in Congo (Republic)?
Keep it short and to the point. 108.51. What is the ratio of the Value added (constant 2005 US$) in 1961 in China to that in Congo (Republic)?
Keep it short and to the point. 71.73. What is the ratio of the Value added (constant 2005 US$) of 1962 in China to that in Congo (Republic)?
Your answer should be compact. 60.67. What is the ratio of the Value added (constant 2005 US$) in 1963 in China to that in Congo (Republic)?
Give a very brief answer. 67.39. What is the ratio of the Value added (constant 2005 US$) in 1960 in China to that in Costa Rica?
Keep it short and to the point. 21.08. What is the ratio of the Value added (constant 2005 US$) in 1961 in China to that in Costa Rica?
Make the answer very short. 16.15. What is the ratio of the Value added (constant 2005 US$) of 1962 in China to that in Costa Rica?
Provide a short and direct response. 13.45. What is the ratio of the Value added (constant 2005 US$) of 1963 in China to that in Costa Rica?
Provide a short and direct response. 13.32. What is the ratio of the Value added (constant 2005 US$) in 1960 in Congo (Republic) to that in Costa Rica?
Give a very brief answer. 0.19. What is the ratio of the Value added (constant 2005 US$) of 1961 in Congo (Republic) to that in Costa Rica?
Your response must be concise. 0.23. What is the ratio of the Value added (constant 2005 US$) in 1962 in Congo (Republic) to that in Costa Rica?
Give a very brief answer. 0.22. What is the ratio of the Value added (constant 2005 US$) in 1963 in Congo (Republic) to that in Costa Rica?
Keep it short and to the point. 0.2. What is the difference between the highest and the second highest Value added (constant 2005 US$) of 1960?
Provide a succinct answer. 2.19e+1. What is the difference between the highest and the second highest Value added (constant 2005 US$) of 1961?
Provide a short and direct response. 1.30e+1. What is the difference between the highest and the second highest Value added (constant 2005 US$) in 1962?
Your answer should be very brief. 1.05e+1. What is the difference between the highest and the second highest Value added (constant 2005 US$) in 1963?
Provide a succinct answer. 1.09e+1. What is the difference between the highest and the lowest Value added (constant 2005 US$) of 1960?
Ensure brevity in your answer.  3.26e+1. What is the difference between the highest and the lowest Value added (constant 2005 US$) in 1961?
Your answer should be very brief. 2.42e+1. What is the difference between the highest and the lowest Value added (constant 2005 US$) in 1962?
Offer a very short reply. 2.19e+1. What is the difference between the highest and the lowest Value added (constant 2005 US$) in 1963?
Provide a short and direct response. 2.29e+1. 